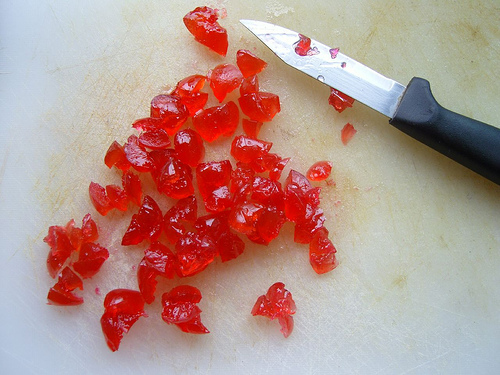<image>
Is the sharp object on the yummy treat? Yes. Looking at the image, I can see the sharp object is positioned on top of the yummy treat, with the yummy treat providing support. Is the jam to the left of the knife? Yes. From this viewpoint, the jam is positioned to the left side relative to the knife. 